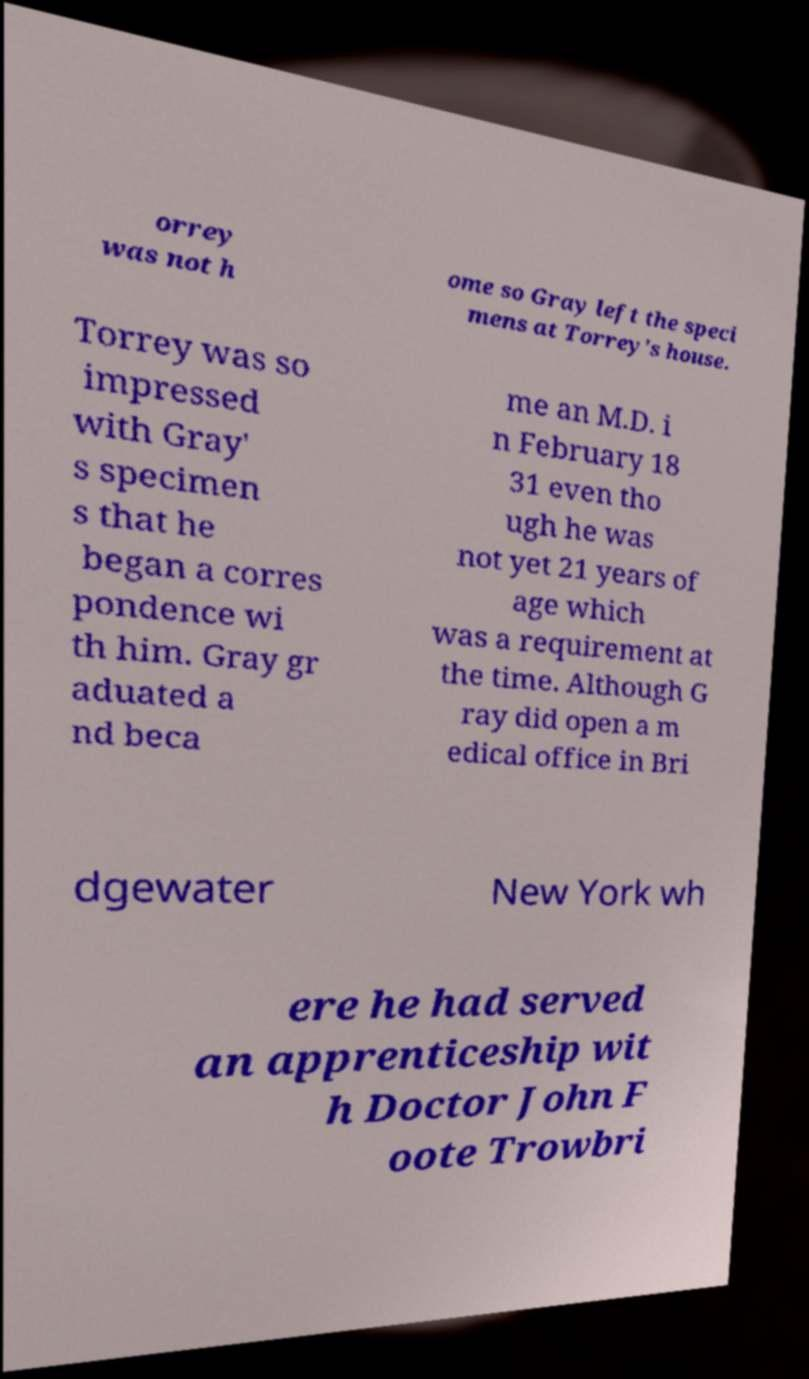Could you extract and type out the text from this image? orrey was not h ome so Gray left the speci mens at Torrey's house. Torrey was so impressed with Gray' s specimen s that he began a corres pondence wi th him. Gray gr aduated a nd beca me an M.D. i n February 18 31 even tho ugh he was not yet 21 years of age which was a requirement at the time. Although G ray did open a m edical office in Bri dgewater New York wh ere he had served an apprenticeship wit h Doctor John F oote Trowbri 